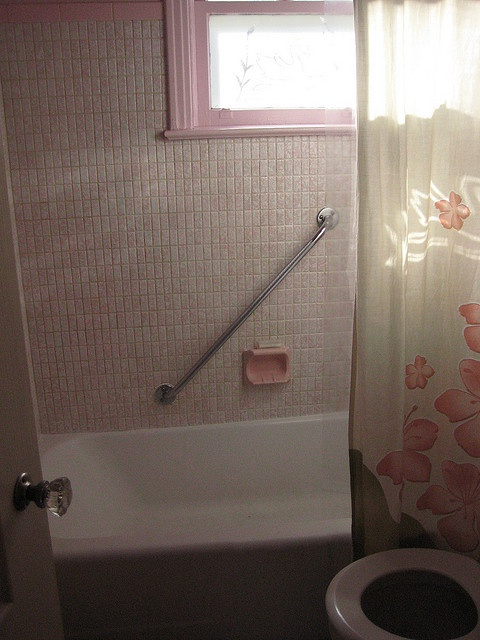Describe the objects in this image and their specific colors. I can see a toilet in black and gray tones in this image. 